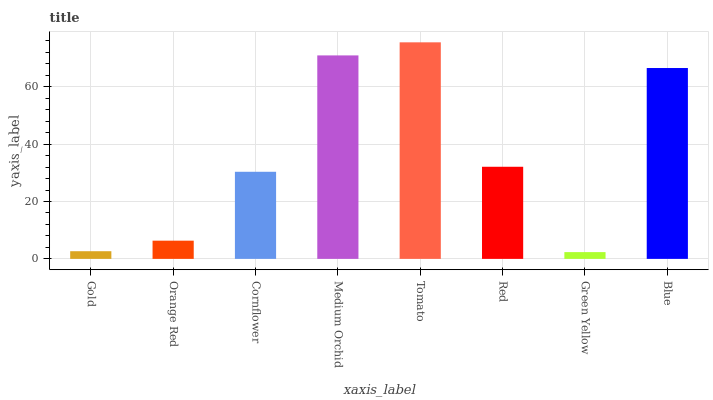Is Green Yellow the minimum?
Answer yes or no. Yes. Is Tomato the maximum?
Answer yes or no. Yes. Is Orange Red the minimum?
Answer yes or no. No. Is Orange Red the maximum?
Answer yes or no. No. Is Orange Red greater than Gold?
Answer yes or no. Yes. Is Gold less than Orange Red?
Answer yes or no. Yes. Is Gold greater than Orange Red?
Answer yes or no. No. Is Orange Red less than Gold?
Answer yes or no. No. Is Red the high median?
Answer yes or no. Yes. Is Cornflower the low median?
Answer yes or no. Yes. Is Gold the high median?
Answer yes or no. No. Is Medium Orchid the low median?
Answer yes or no. No. 